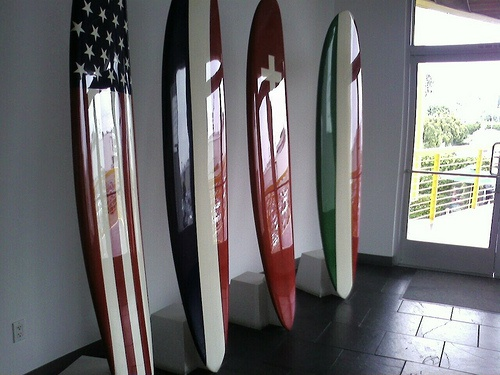Describe the objects in this image and their specific colors. I can see surfboard in gray, black, darkgray, maroon, and lightgray tones, surfboard in gray, black, darkgray, and lightgray tones, surfboard in gray, black, maroon, lavender, and brown tones, and surfboard in gray, darkgray, black, and teal tones in this image. 